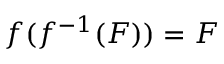Convert formula to latex. <formula><loc_0><loc_0><loc_500><loc_500>f ( f ^ { - 1 } ( F ) ) = F</formula> 